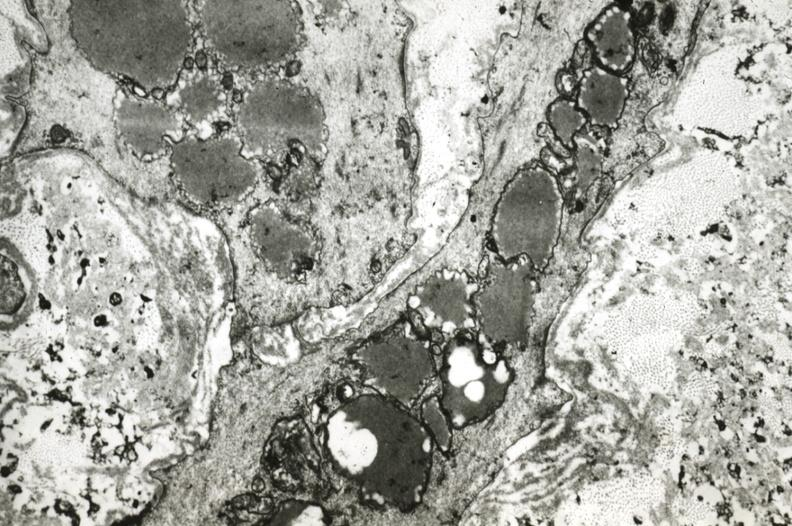does peritoneum show intimal smooth muscle cells with lipid in cytoplasm and precipitated lipid in interstitial space?
Answer the question using a single word or phrase. No 